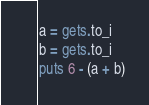Convert code to text. <code><loc_0><loc_0><loc_500><loc_500><_Ruby_>a = gets.to_i
b = gets.to_i
puts 6 - (a + b)
</code> 